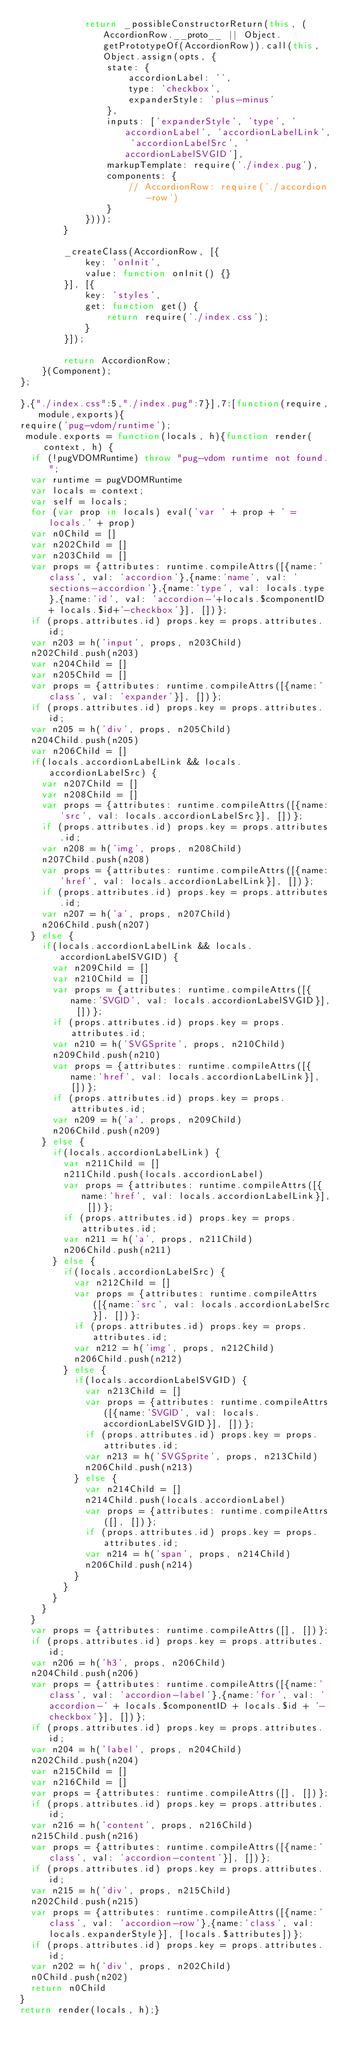Convert code to text. <code><loc_0><loc_0><loc_500><loc_500><_JavaScript_>            return _possibleConstructorReturn(this, (AccordionRow.__proto__ || Object.getPrototypeOf(AccordionRow)).call(this, Object.assign(opts, {
                state: {
                    accordionLabel: '',
                    type: 'checkbox',
                    expanderStyle: 'plus-minus'
                },
                inputs: ['expanderStyle', 'type', 'accordionLabel', 'accordionLabelLink', 'accordionLabelSrc', 'accordionLabelSVGID'],
                markupTemplate: require('./index.pug'),
                components: {
                    // AccordionRow: require('./accordion-row')
                }
            })));
        }

        _createClass(AccordionRow, [{
            key: 'onInit',
            value: function onInit() {}
        }], [{
            key: 'styles',
            get: function get() {
                return require('./index.css');
            }
        }]);

        return AccordionRow;
    }(Component);
};

},{"./index.css":5,"./index.pug":7}],7:[function(require,module,exports){
require('pug-vdom/runtime');
 module.exports = function(locals, h){function render(context, h) {
  if (!pugVDOMRuntime) throw "pug-vdom runtime not found.";
  var runtime = pugVDOMRuntime
  var locals = context;
  var self = locals;
  for (var prop in locals) eval('var ' + prop + ' =  locals.' + prop)
  var n0Child = []
  var n202Child = []
  var n203Child = []
  var props = {attributes: runtime.compileAttrs([{name:'class', val: 'accordion'},{name:'name', val: 'sections-accordion'},{name:'type', val: locals.type},{name:'id', val: 'accordion-'+locals.$componentID + locals.$id+'-checkbox'}], [])};
  if (props.attributes.id) props.key = props.attributes.id;
  var n203 = h('input', props, n203Child)
  n202Child.push(n203)
  var n204Child = []
  var n205Child = []
  var props = {attributes: runtime.compileAttrs([{name:'class', val: 'expander'}], [])};
  if (props.attributes.id) props.key = props.attributes.id;
  var n205 = h('div', props, n205Child)
  n204Child.push(n205)
  var n206Child = []
  if(locals.accordionLabelLink && locals.accordionLabelSrc) {
    var n207Child = []
    var n208Child = []
    var props = {attributes: runtime.compileAttrs([{name:'src', val: locals.accordionLabelSrc}], [])};
    if (props.attributes.id) props.key = props.attributes.id;
    var n208 = h('img', props, n208Child)
    n207Child.push(n208)
    var props = {attributes: runtime.compileAttrs([{name:'href', val: locals.accordionLabelLink}], [])};
    if (props.attributes.id) props.key = props.attributes.id;
    var n207 = h('a', props, n207Child)
    n206Child.push(n207)
  } else {
    if(locals.accordionLabelLink && locals.accordionLabelSVGID) {
      var n209Child = []
      var n210Child = []
      var props = {attributes: runtime.compileAttrs([{name:'SVGID', val: locals.accordionLabelSVGID}], [])};
      if (props.attributes.id) props.key = props.attributes.id;
      var n210 = h('SVGSprite', props, n210Child)
      n209Child.push(n210)
      var props = {attributes: runtime.compileAttrs([{name:'href', val: locals.accordionLabelLink}], [])};
      if (props.attributes.id) props.key = props.attributes.id;
      var n209 = h('a', props, n209Child)
      n206Child.push(n209)
    } else {
      if(locals.accordionLabelLink) {
        var n211Child = []
        n211Child.push(locals.accordionLabel)
        var props = {attributes: runtime.compileAttrs([{name:'href', val: locals.accordionLabelLink}], [])};
        if (props.attributes.id) props.key = props.attributes.id;
        var n211 = h('a', props, n211Child)
        n206Child.push(n211)
      } else {
        if(locals.accordionLabelSrc) {
          var n212Child = []
          var props = {attributes: runtime.compileAttrs([{name:'src', val: locals.accordionLabelSrc}], [])};
          if (props.attributes.id) props.key = props.attributes.id;
          var n212 = h('img', props, n212Child)
          n206Child.push(n212)
        } else {
          if(locals.accordionLabelSVGID) {
            var n213Child = []
            var props = {attributes: runtime.compileAttrs([{name:'SVGID', val: locals.accordionLabelSVGID}], [])};
            if (props.attributes.id) props.key = props.attributes.id;
            var n213 = h('SVGSprite', props, n213Child)
            n206Child.push(n213)
          } else {
            var n214Child = []
            n214Child.push(locals.accordionLabel)
            var props = {attributes: runtime.compileAttrs([], [])};
            if (props.attributes.id) props.key = props.attributes.id;
            var n214 = h('span', props, n214Child)
            n206Child.push(n214)
          }
        }
      }
    }
  }
  var props = {attributes: runtime.compileAttrs([], [])};
  if (props.attributes.id) props.key = props.attributes.id;
  var n206 = h('h3', props, n206Child)
  n204Child.push(n206)
  var props = {attributes: runtime.compileAttrs([{name:'class', val: 'accordion-label'},{name:'for', val: 'accordion-' + locals.$componentID + locals.$id + '-checkbox'}], [])};
  if (props.attributes.id) props.key = props.attributes.id;
  var n204 = h('label', props, n204Child)
  n202Child.push(n204)
  var n215Child = []
  var n216Child = []
  var props = {attributes: runtime.compileAttrs([], [])};
  if (props.attributes.id) props.key = props.attributes.id;
  var n216 = h('content', props, n216Child)
  n215Child.push(n216)
  var props = {attributes: runtime.compileAttrs([{name:'class', val: 'accordion-content'}], [])};
  if (props.attributes.id) props.key = props.attributes.id;
  var n215 = h('div', props, n215Child)
  n202Child.push(n215)
  var props = {attributes: runtime.compileAttrs([{name:'class', val: 'accordion-row'},{name:'class', val: locals.expanderStyle}], [locals.$attributes])};
  if (props.attributes.id) props.key = props.attributes.id;
  var n202 = h('div', props, n202Child)
  n0Child.push(n202)
  return n0Child
}
return render(locals, h);}</code> 